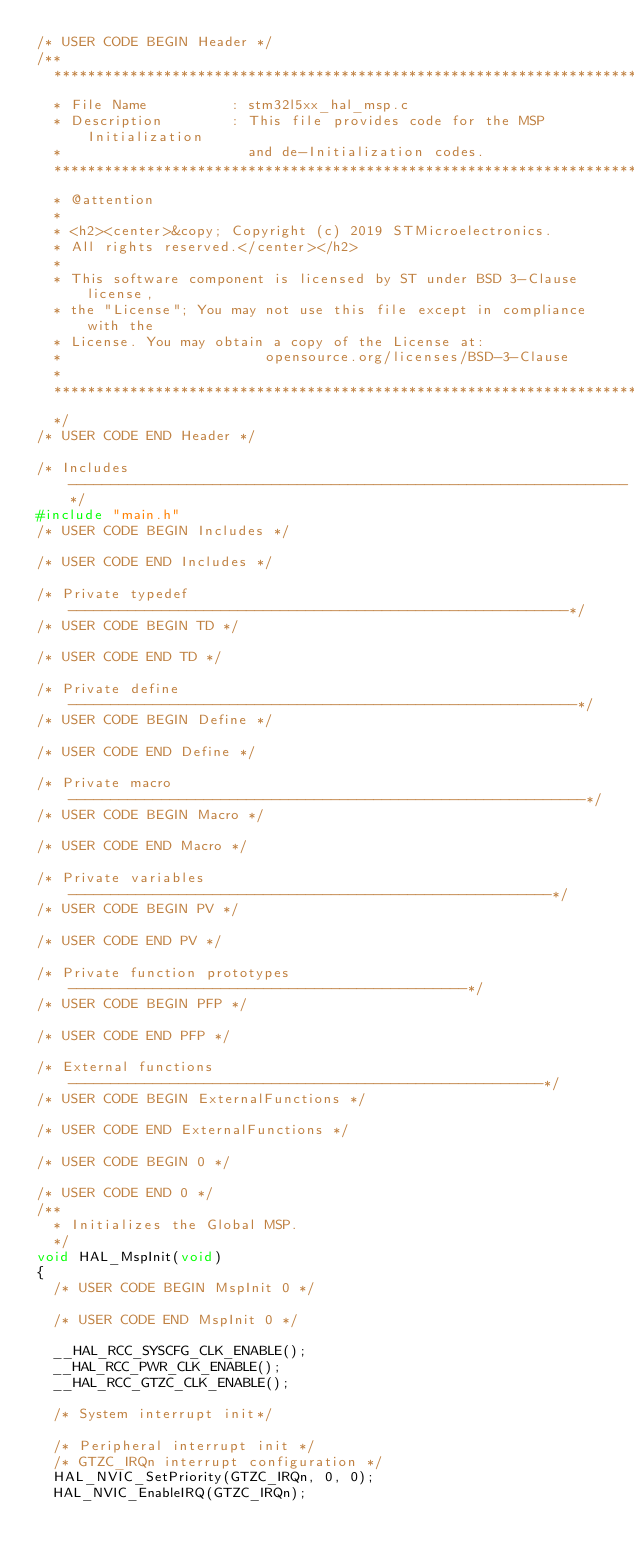Convert code to text. <code><loc_0><loc_0><loc_500><loc_500><_C_>/* USER CODE BEGIN Header */
/**
  ******************************************************************************
  * File Name          : stm32l5xx_hal_msp.c
  * Description        : This file provides code for the MSP Initialization
  *                      and de-Initialization codes.
  ******************************************************************************
  * @attention
  *
  * <h2><center>&copy; Copyright (c) 2019 STMicroelectronics.
  * All rights reserved.</center></h2>
  *
  * This software component is licensed by ST under BSD 3-Clause license,
  * the "License"; You may not use this file except in compliance with the
  * License. You may obtain a copy of the License at:
  *                        opensource.org/licenses/BSD-3-Clause
  *
  ******************************************************************************
  */
/* USER CODE END Header */

/* Includes ------------------------------------------------------------------*/
#include "main.h"
/* USER CODE BEGIN Includes */

/* USER CODE END Includes */

/* Private typedef -----------------------------------------------------------*/
/* USER CODE BEGIN TD */

/* USER CODE END TD */

/* Private define ------------------------------------------------------------*/
/* USER CODE BEGIN Define */

/* USER CODE END Define */

/* Private macro -------------------------------------------------------------*/
/* USER CODE BEGIN Macro */

/* USER CODE END Macro */

/* Private variables ---------------------------------------------------------*/
/* USER CODE BEGIN PV */

/* USER CODE END PV */

/* Private function prototypes -----------------------------------------------*/
/* USER CODE BEGIN PFP */

/* USER CODE END PFP */

/* External functions --------------------------------------------------------*/
/* USER CODE BEGIN ExternalFunctions */

/* USER CODE END ExternalFunctions */

/* USER CODE BEGIN 0 */

/* USER CODE END 0 */
/**
  * Initializes the Global MSP.
  */
void HAL_MspInit(void)
{
  /* USER CODE BEGIN MspInit 0 */

  /* USER CODE END MspInit 0 */

  __HAL_RCC_SYSCFG_CLK_ENABLE();
  __HAL_RCC_PWR_CLK_ENABLE();
  __HAL_RCC_GTZC_CLK_ENABLE();

  /* System interrupt init*/

  /* Peripheral interrupt init */
  /* GTZC_IRQn interrupt configuration */
  HAL_NVIC_SetPriority(GTZC_IRQn, 0, 0);
  HAL_NVIC_EnableIRQ(GTZC_IRQn);
</code> 